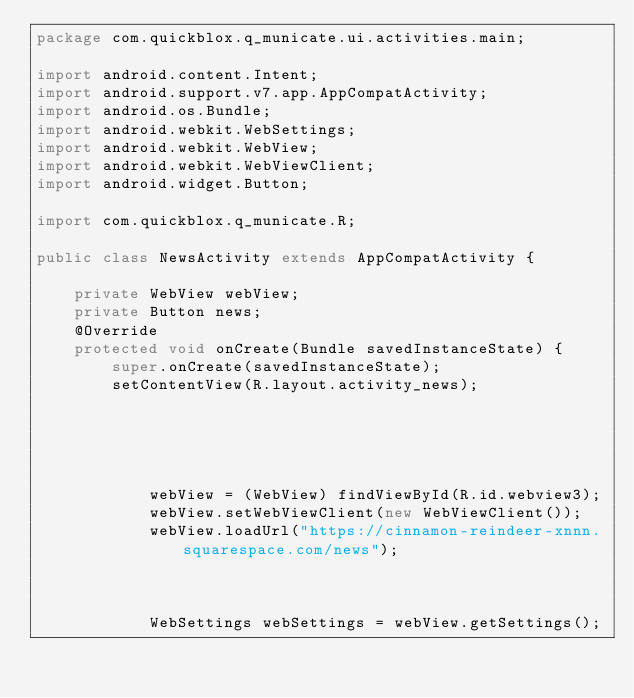<code> <loc_0><loc_0><loc_500><loc_500><_Java_>package com.quickblox.q_municate.ui.activities.main;

import android.content.Intent;
import android.support.v7.app.AppCompatActivity;
import android.os.Bundle;
import android.webkit.WebSettings;
import android.webkit.WebView;
import android.webkit.WebViewClient;
import android.widget.Button;

import com.quickblox.q_municate.R;

public class NewsActivity extends AppCompatActivity {

    private WebView webView;
    private Button news;
    @Override
    protected void onCreate(Bundle savedInstanceState) {
        super.onCreate(savedInstanceState);
        setContentView(R.layout.activity_news);





            webView = (WebView) findViewById(R.id.webview3);
            webView.setWebViewClient(new WebViewClient());
            webView.loadUrl("https://cinnamon-reindeer-xnnn.squarespace.com/news");



            WebSettings webSettings = webView.getSettings();</code> 